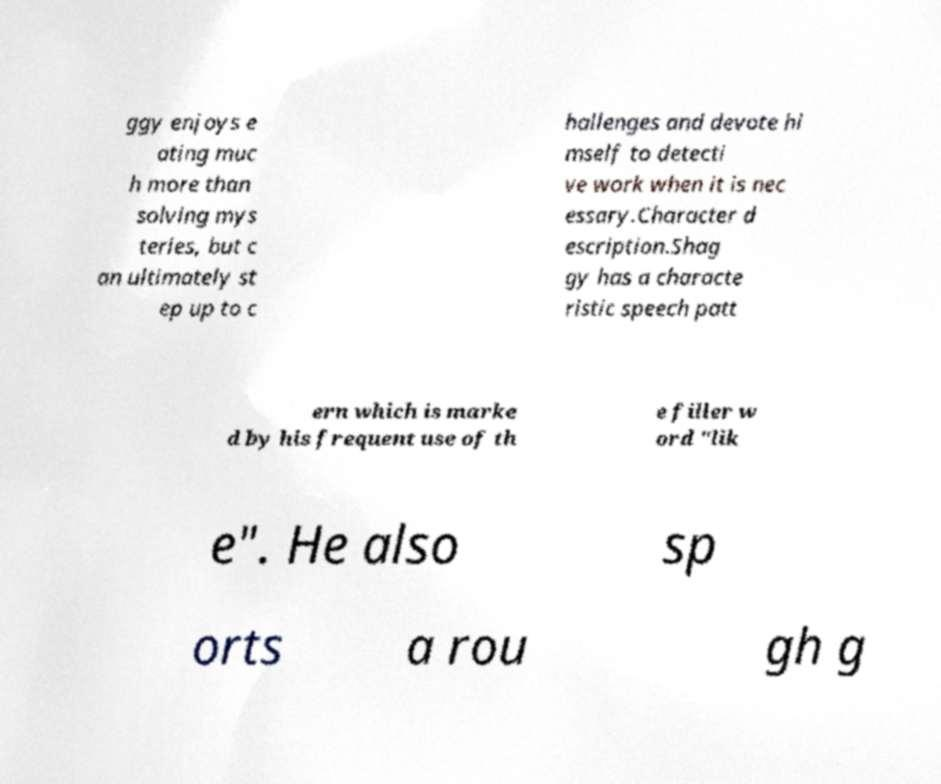Can you accurately transcribe the text from the provided image for me? ggy enjoys e ating muc h more than solving mys teries, but c an ultimately st ep up to c hallenges and devote hi mself to detecti ve work when it is nec essary.Character d escription.Shag gy has a characte ristic speech patt ern which is marke d by his frequent use of th e filler w ord "lik e". He also sp orts a rou gh g 